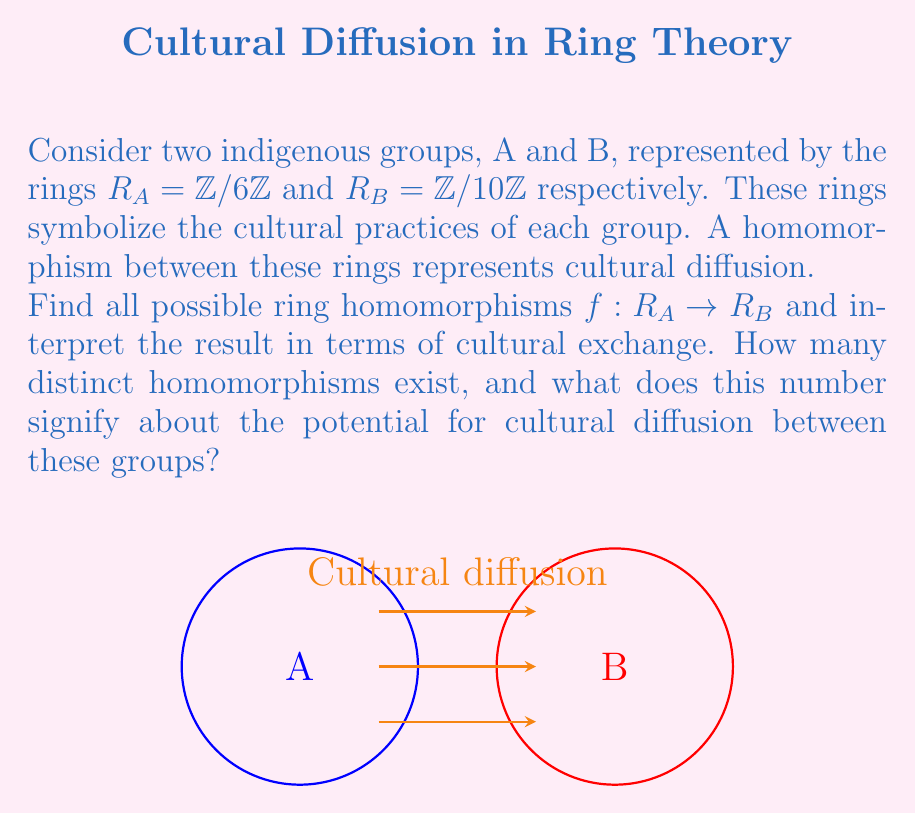Help me with this question. Let's approach this step-by-step:

1) First, recall that a ring homomorphism $f: R_A \rightarrow R_B$ must satisfy:
   a) $f(a+b) = f(a) + f(b)$ for all $a,b \in R_A$
   b) $f(ab) = f(a)f(b)$ for all $a,b \in R_A$
   c) $f(1_{R_A}) = 1_{R_B}$ if $R_A$ has a multiplicative identity

2) In our case, $R_A = \mathbb{Z}/6\mathbb{Z}$ and $R_B = \mathbb{Z}/10\mathbb{Z}$. Both have multiplicative identities.

3) A key property of ring homomorphisms is that $f(0_{R_A}) = 0_{R_B}$. So, we must have $f(0) = 0$.

4) Also, $f(1_{R_A}) = 1_{R_B}$ or $f(1_{R_A}) = 6_{R_B}$, as these are the only elements in $R_B$ that square to themselves.

5) If $f(1_{R_A}) = 6_{R_B}$, then $f(2_{R_A}) = f(1_{R_A} + 1_{R_A}) = f(1_{R_A}) + f(1_{R_A}) = 6_{R_B} + 6_{R_B} = 2_{R_B}$. This contradicts $f(2_{R_A})f(3_{R_A}) = f(6_{R_A}) = f(0_{R_A}) = 0_{R_B}$. So, we must have $f(1_{R_A}) = 1_{R_B}$.

6) Now, $f$ is completely determined by $f(1_{R_A})$ because:
   $f(2_{R_A}) = f(1_{R_A} + 1_{R_A}) = f(1_{R_A}) + f(1_{R_A}) = 1_{R_B} + 1_{R_B} = 2_{R_B}$
   $f(3_{R_A}) = f(1_{R_A} + 2_{R_A}) = f(1_{R_A}) + f(2_{R_A}) = 1_{R_B} + 2_{R_B} = 3_{R_B}$
   $f(4_{R_A}) = f(2_{R_A} + 2_{R_A}) = f(2_{R_A}) + f(2_{R_A}) = 2_{R_B} + 2_{R_B} = 4_{R_B}$
   $f(5_{R_A}) = f(1_{R_A} + 4_{R_A}) = f(1_{R_A}) + f(4_{R_A}) = 1_{R_B} + 4_{R_B} = 5_{R_B}$

7) This homomorphism satisfies all the required properties, and it's the only one possible.

Interpretation: The existence of only one homomorphism suggests a limited pathway for cultural diffusion between these two groups. This single channel of exchange might represent a specific shared cultural practice or belief system that allows for the transfer of ideas between the groups.
Answer: 1 homomorphism; limited cultural diffusion potential 